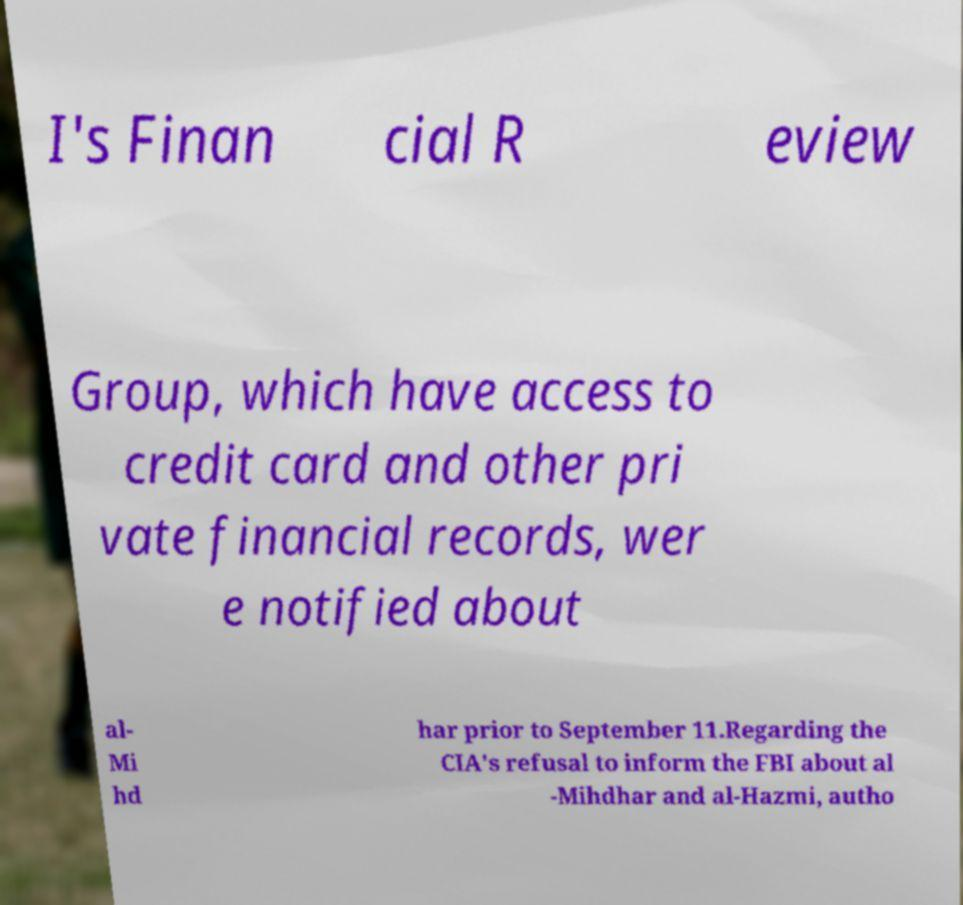For documentation purposes, I need the text within this image transcribed. Could you provide that? I's Finan cial R eview Group, which have access to credit card and other pri vate financial records, wer e notified about al- Mi hd har prior to September 11.Regarding the CIA's refusal to inform the FBI about al -Mihdhar and al-Hazmi, autho 